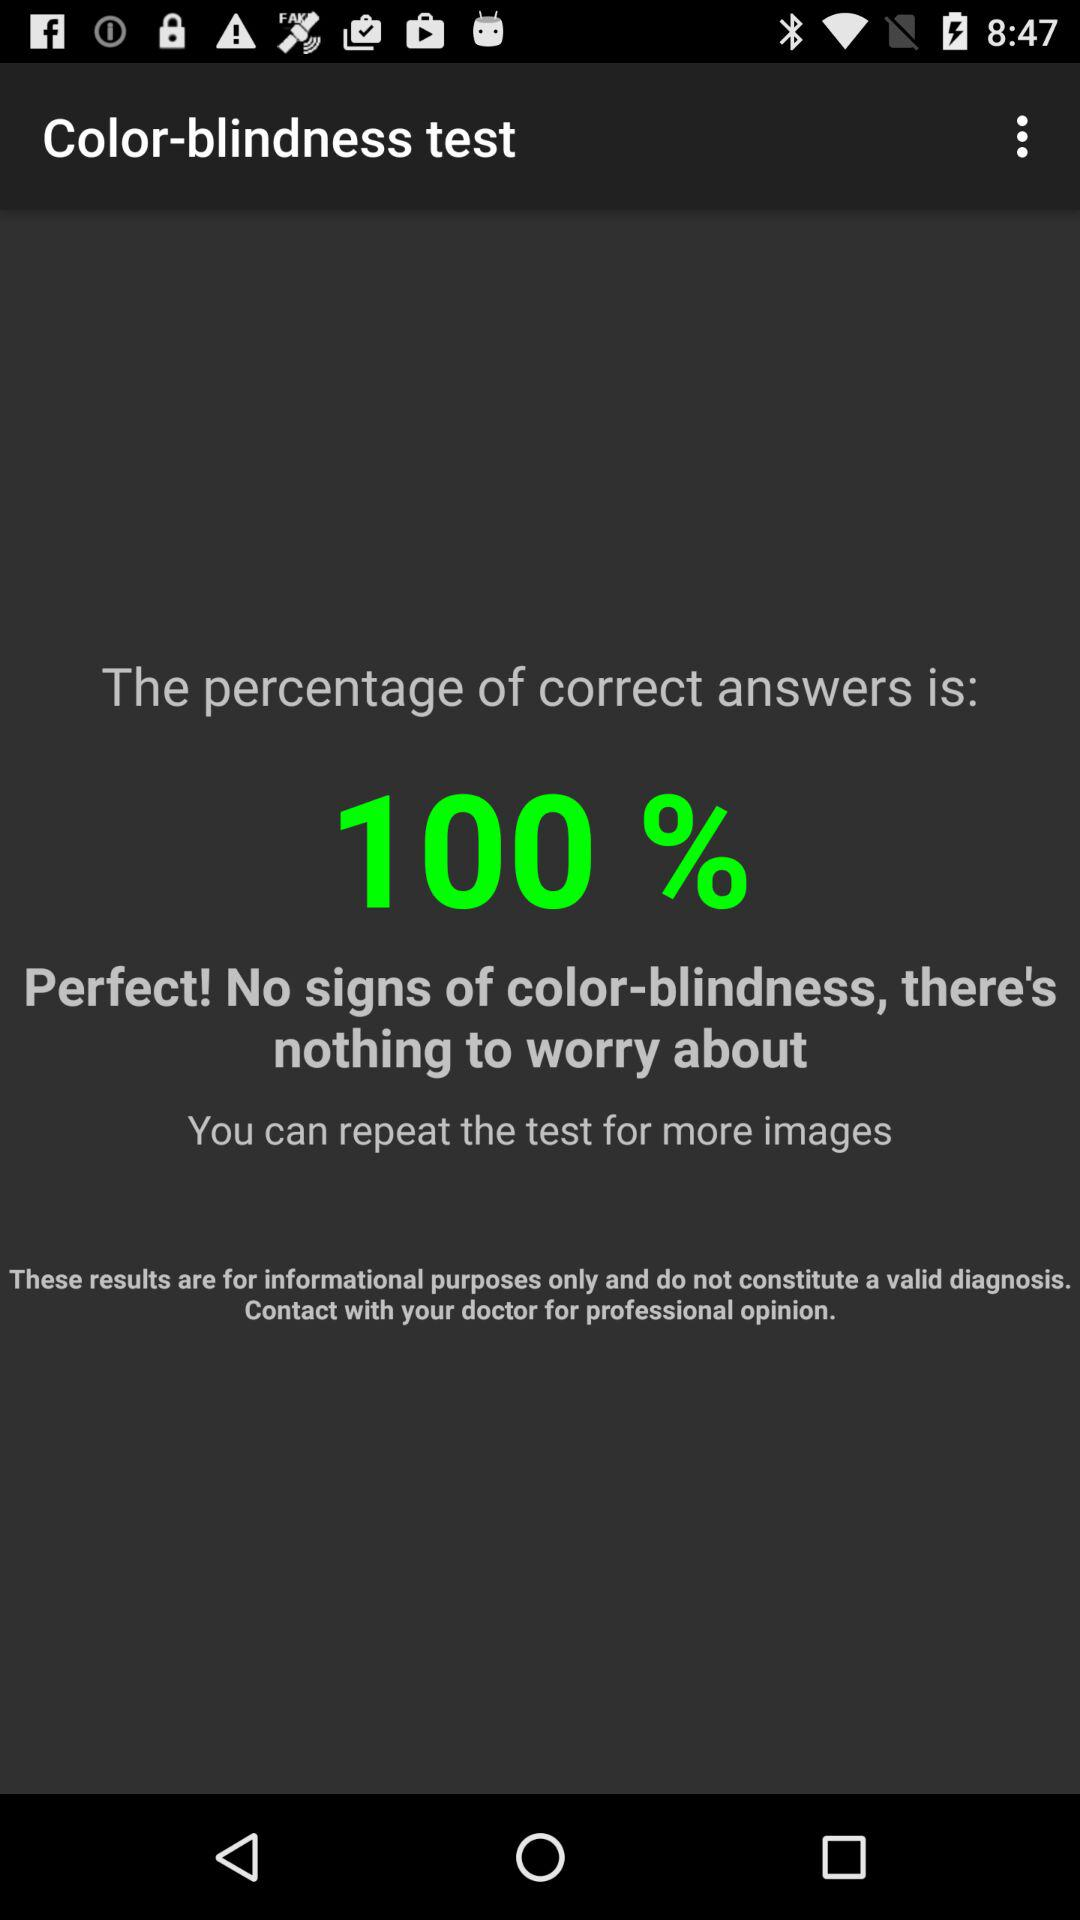When was the color blindness test taken?
When the provided information is insufficient, respond with <no answer>. <no answer> 